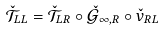<formula> <loc_0><loc_0><loc_500><loc_500>\check { \mathcal { T } } _ { L L } = \check { \mathcal { T } } _ { L R } \circ \check { \mathcal { G } } _ { \infty , R } \circ \check { v } _ { R L }</formula> 